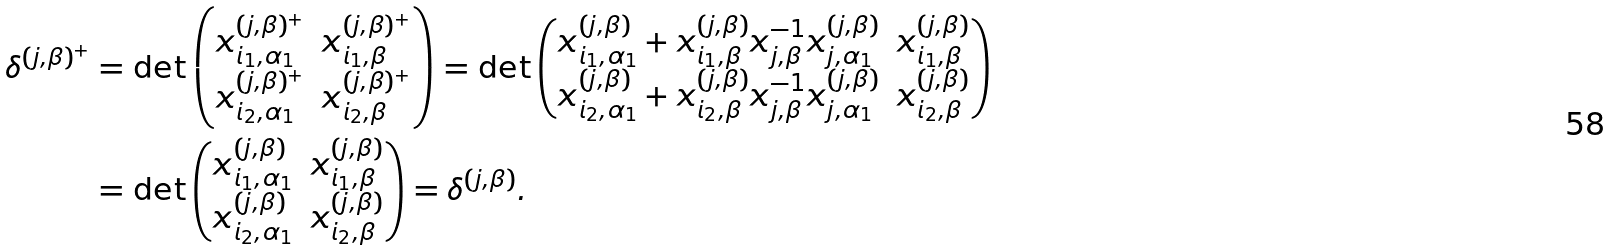<formula> <loc_0><loc_0><loc_500><loc_500>\delta ^ { ( j , \beta ) ^ { + } } & = \det \begin{pmatrix} x _ { i _ { 1 } , \alpha _ { 1 } } ^ { ( j , \beta ) ^ { + } } & x _ { i _ { 1 } , \beta } ^ { ( j , \beta ) ^ { + } } \\ x _ { i _ { 2 } , \alpha _ { 1 } } ^ { ( j , \beta ) ^ { + } } & x _ { i _ { 2 } , \beta } ^ { ( j , \beta ) ^ { + } } \end{pmatrix} = \det \begin{pmatrix} x _ { i _ { 1 } , \alpha _ { 1 } } ^ { ( j , \beta ) } + x _ { i _ { 1 } , \beta } ^ { ( j , \beta ) } x _ { j , \beta } ^ { - 1 } x _ { j , \alpha _ { 1 } } ^ { ( j , \beta ) } & x _ { i _ { 1 } , \beta } ^ { ( j , \beta ) } \\ x _ { i _ { 2 } , \alpha _ { 1 } } ^ { ( j , \beta ) } + x _ { i _ { 2 } , \beta } ^ { ( j , \beta ) } x _ { j , \beta } ^ { - 1 } x _ { j , \alpha _ { 1 } } ^ { ( j , \beta ) } & x _ { i _ { 2 } , \beta } ^ { ( j , \beta ) } \end{pmatrix} \\ & = \det \begin{pmatrix} x _ { i _ { 1 } , \alpha _ { 1 } } ^ { ( j , \beta ) } & x _ { i _ { 1 } , \beta } ^ { ( j , \beta ) } \\ x _ { i _ { 2 } , \alpha _ { 1 } } ^ { ( j , \beta ) } & x _ { i _ { 2 } , \beta } ^ { ( j , \beta ) } \end{pmatrix} = \delta ^ { ( j , \beta ) } .</formula> 